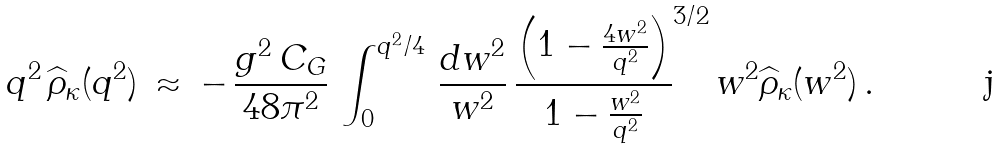<formula> <loc_0><loc_0><loc_500><loc_500>q ^ { 2 } \, \widehat { \rho } _ { \kappa } ( q ^ { 2 } ) \, \approx \, - \, \frac { g ^ { 2 } \, C _ { G } } { 4 8 \pi ^ { 2 } } \, \int _ { 0 } ^ { q ^ { 2 } / 4 } \, \frac { d w ^ { 2 } } { w ^ { 2 } } \, \frac { \left ( 1 - \frac { 4 w ^ { 2 } } { q ^ { 2 } } \right ) } { 1 - \frac { w ^ { 2 } } { q ^ { 2 } } } ^ { 3 / 2 } \, w ^ { 2 } \widehat { \rho } _ { \kappa } ( w ^ { 2 } ) \, .</formula> 